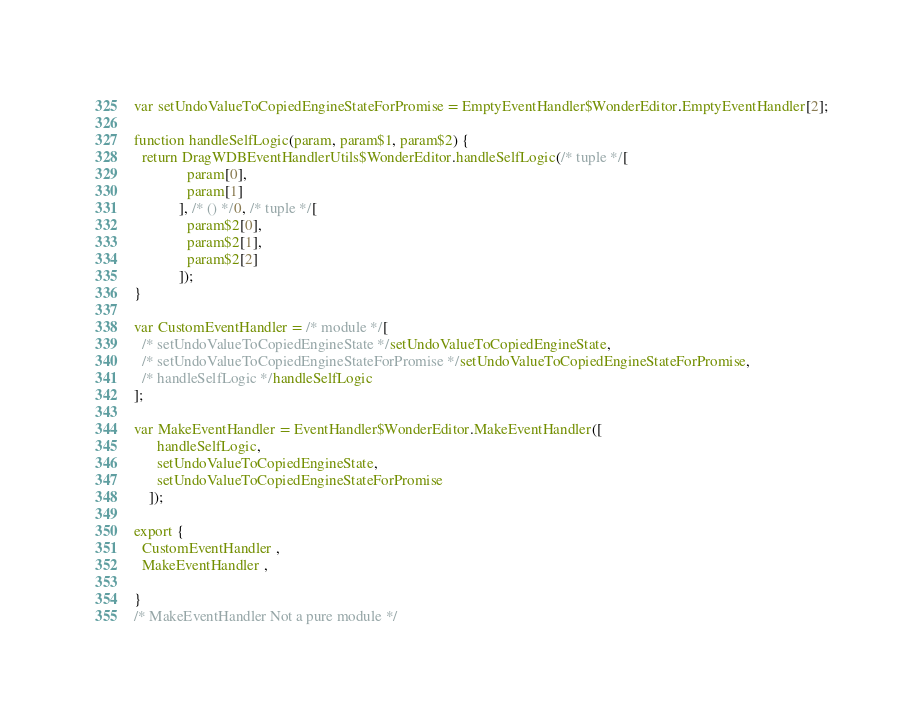Convert code to text. <code><loc_0><loc_0><loc_500><loc_500><_JavaScript_>
var setUndoValueToCopiedEngineStateForPromise = EmptyEventHandler$WonderEditor.EmptyEventHandler[2];

function handleSelfLogic(param, param$1, param$2) {
  return DragWDBEventHandlerUtils$WonderEditor.handleSelfLogic(/* tuple */[
              param[0],
              param[1]
            ], /* () */0, /* tuple */[
              param$2[0],
              param$2[1],
              param$2[2]
            ]);
}

var CustomEventHandler = /* module */[
  /* setUndoValueToCopiedEngineState */setUndoValueToCopiedEngineState,
  /* setUndoValueToCopiedEngineStateForPromise */setUndoValueToCopiedEngineStateForPromise,
  /* handleSelfLogic */handleSelfLogic
];

var MakeEventHandler = EventHandler$WonderEditor.MakeEventHandler([
      handleSelfLogic,
      setUndoValueToCopiedEngineState,
      setUndoValueToCopiedEngineStateForPromise
    ]);

export {
  CustomEventHandler ,
  MakeEventHandler ,
  
}
/* MakeEventHandler Not a pure module */
</code> 